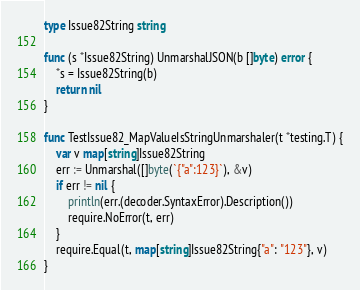<code> <loc_0><loc_0><loc_500><loc_500><_Go_>type Issue82String string

func (s *Issue82String) UnmarshalJSON(b []byte) error {
    *s = Issue82String(b)
    return nil
}

func TestIssue82_MapValueIsStringUnmarshaler(t *testing.T) {
    var v map[string]Issue82String
    err := Unmarshal([]byte(`{"a":123}`), &v)
    if err != nil {
        println(err.(decoder.SyntaxError).Description())
        require.NoError(t, err)
    }
    require.Equal(t, map[string]Issue82String{"a": "123"}, v)
}
</code> 